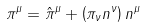<formula> <loc_0><loc_0><loc_500><loc_500>\pi ^ { \mu } = \hat { \pi } ^ { \mu } + \left ( \pi _ { \nu } n ^ { \nu } \right ) n ^ { \mu }</formula> 